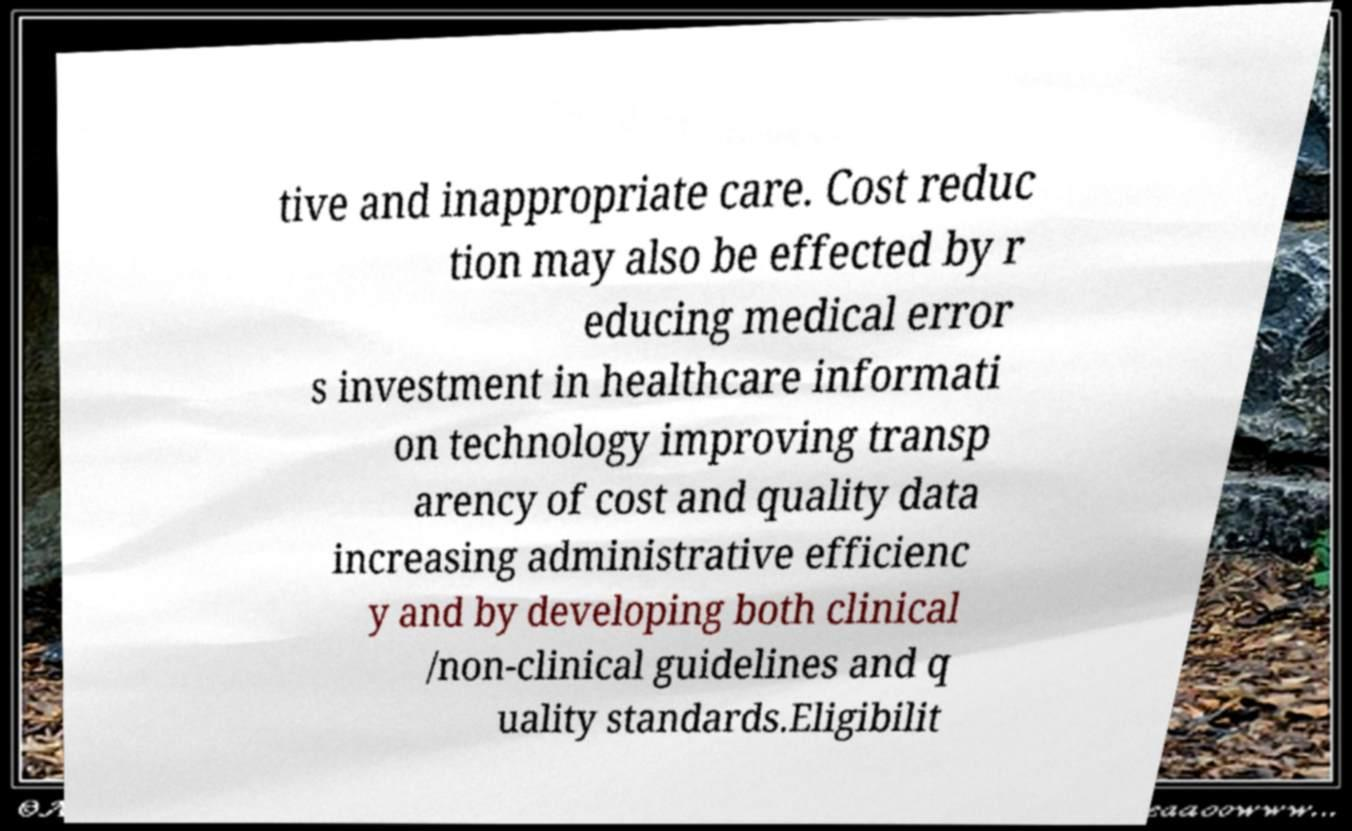Please read and relay the text visible in this image. What does it say? tive and inappropriate care. Cost reduc tion may also be effected by r educing medical error s investment in healthcare informati on technology improving transp arency of cost and quality data increasing administrative efficienc y and by developing both clinical /non-clinical guidelines and q uality standards.Eligibilit 